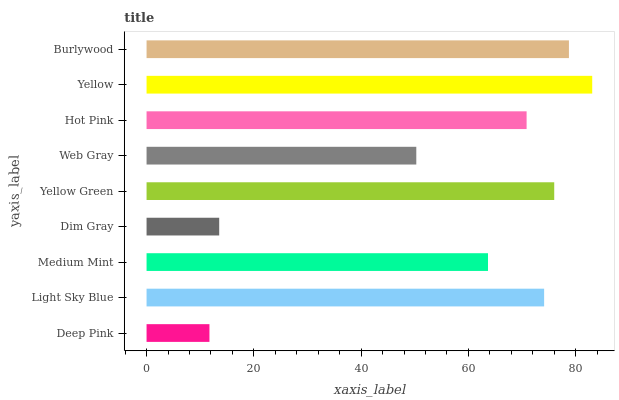Is Deep Pink the minimum?
Answer yes or no. Yes. Is Yellow the maximum?
Answer yes or no. Yes. Is Light Sky Blue the minimum?
Answer yes or no. No. Is Light Sky Blue the maximum?
Answer yes or no. No. Is Light Sky Blue greater than Deep Pink?
Answer yes or no. Yes. Is Deep Pink less than Light Sky Blue?
Answer yes or no. Yes. Is Deep Pink greater than Light Sky Blue?
Answer yes or no. No. Is Light Sky Blue less than Deep Pink?
Answer yes or no. No. Is Hot Pink the high median?
Answer yes or no. Yes. Is Hot Pink the low median?
Answer yes or no. Yes. Is Yellow the high median?
Answer yes or no. No. Is Yellow the low median?
Answer yes or no. No. 